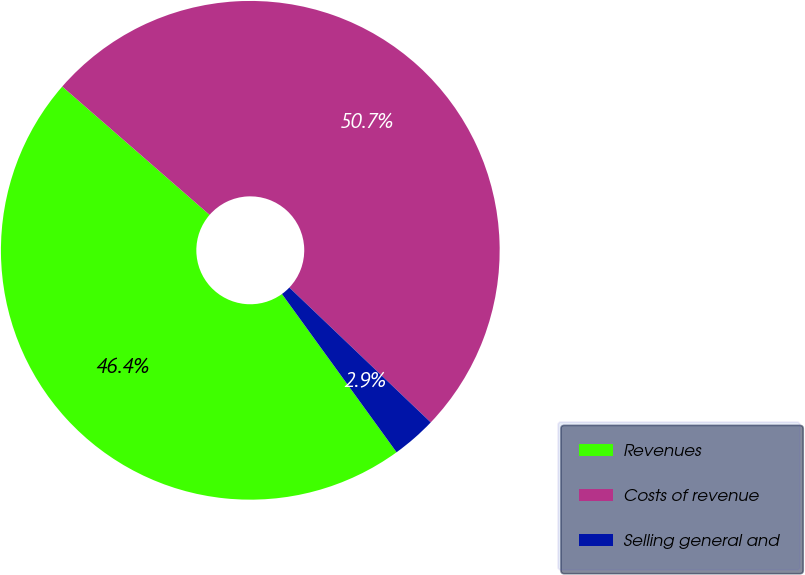<chart> <loc_0><loc_0><loc_500><loc_500><pie_chart><fcel>Revenues<fcel>Costs of revenue<fcel>Selling general and<nl><fcel>46.38%<fcel>50.72%<fcel>2.9%<nl></chart> 